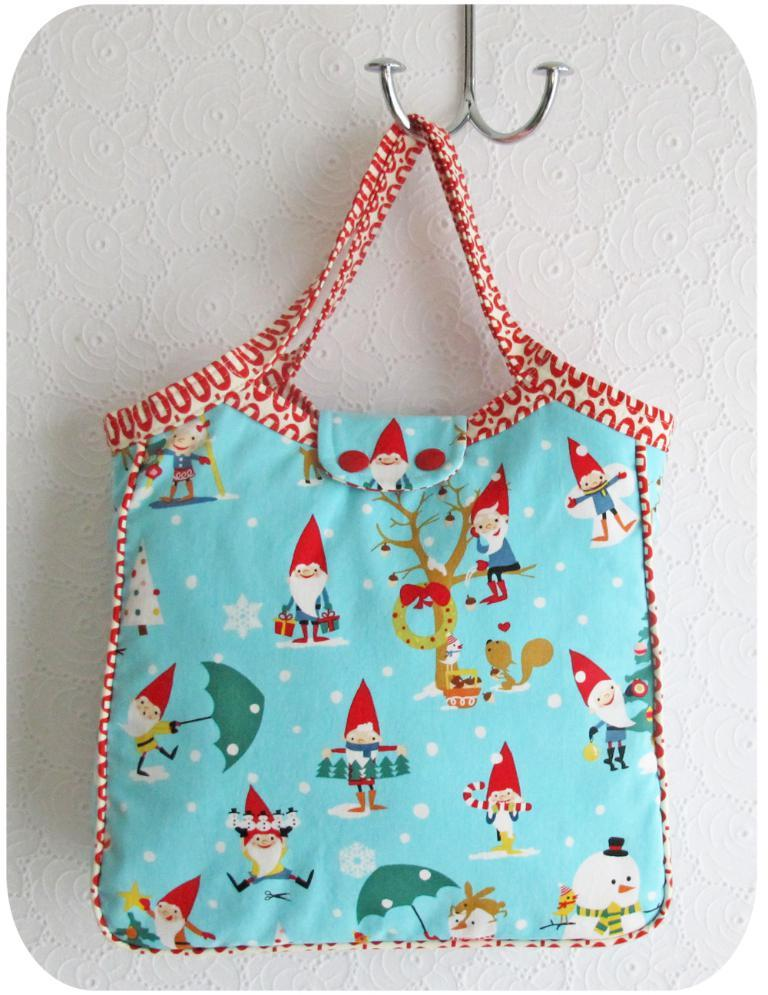What color is the bag that is visible in the image? The bag is blue in color. How is the bag positioned in the image? The bag is on a hanger. What items are inside the bag? There are toys in the bag. What type of beam is holding up the ceiling in the image? There is no beam visible in the image; it only shows a blue color bag on a hanger with toys inside. 